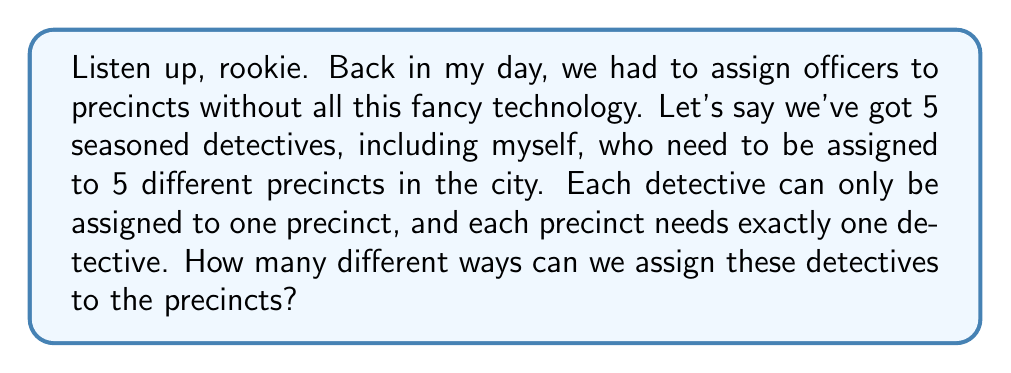Show me your answer to this math problem. Alright, let me break it down for you:

1) This is a classic permutation problem. We're arranging 5 detectives into 5 positions (precincts).

2) For the first precinct, we have 5 choices of detectives to assign.

3) After assigning the first detective, we're left with 4 detectives for the second precinct.

4) For the third precinct, we'll have 3 detectives to choose from.

5) Then 2 for the fourth precinct.

6) And finally, only 1 detective left for the last precinct.

7) Using the multiplication principle, we multiply these numbers together:

   $$5 \times 4 \times 3 \times 2 \times 1$$

8) This is also known as 5 factorial, written as $5!$

9) Let's calculate:
   $$5! = 5 \times 4 \times 3 \times 2 \times 1 = 120$$

So, there are 120 different ways to assign these 5 detectives to 5 precincts.

This is why we always said in the force, "There's more than one way to crack a case." In fact, there are 120 ways in this scenario!
Answer: $120$ ways 